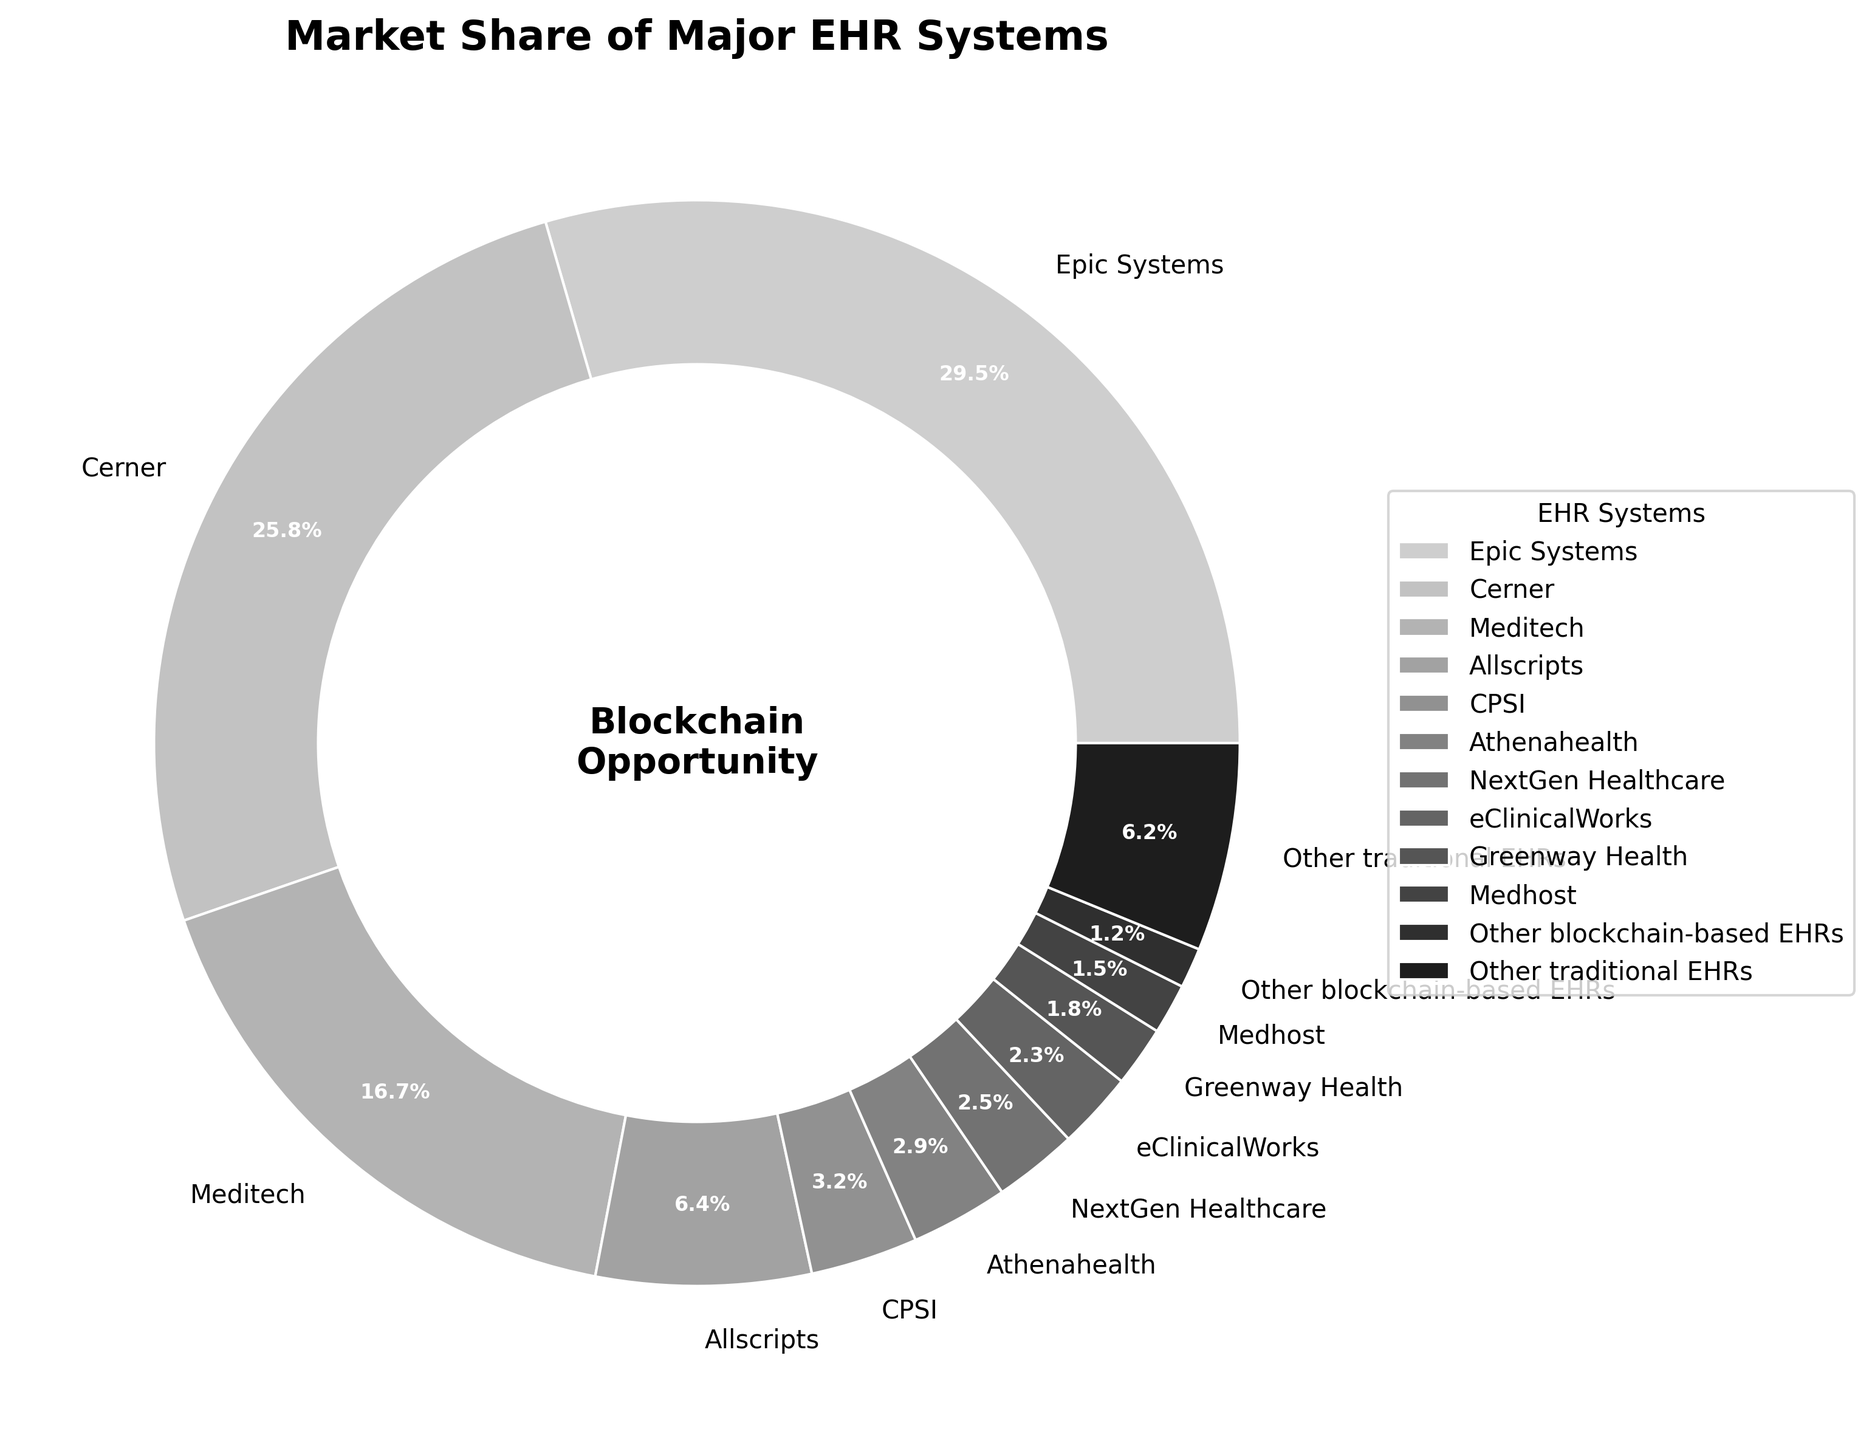Which EHR system has the highest market share? The pie chart shows the market share distribution of various EHR systems with Epic Systems having the largest slice.
Answer: Epic Systems What is the combined market share of Epic Systems and Cerner? To find the combined market share, add the percentages of Epic Systems (29.5%) and Cerner (25.8%). The total is 29.5 + 25.8 = 55.3%.
Answer: 55.3% Which two EHR systems have nearly equal market shares? The chart shows Athenahealth with 2.9% and NextGen Healthcare with 2.5%, which are close to each other in market share.
Answer: Athenahealth and NextGen Healthcare What is the difference in market share between Epic Systems and Meditech? To find the difference, subtract Meditech's share (16.7%) from Epic Systems' share (29.5%). The difference is 29.5 - 16.7 = 12.8%.
Answer: 12.8% Which EHR systems occupy less than 5% of the market share each? The EHR systems with less than 5% market share are Allscripts (6.4%), CPSI (3.2%), Athenahealth (2.9%), NextGen Healthcare (2.5%), eClinicalWorks (2.3%), Greenway Health (1.8%), Medhost (1.5%), other blockchain-based EHRs (1.2%), and other traditional EHRs (6.2%). We exclude 'Other traditional EHRs' since it has 6.2%, which is more than 5%.
Answer: Allscripts, CPSI, Athenahealth, NextGen Healthcare, eClinicalWorks, Greenway Health, Medhost, other blockchain-based EHRs What is the total market share held by blockchain-based EHR systems as indicated in the figure? The figure explicitly shows 'Other blockchain-based EHRs' with a market share of 1.2%.
Answer: 1.2% How much larger is Epic Systems' market share compared to Athenahealth? Subtract Athenahealth's market share (2.9%) from Epic Systems' market share (29.5%). The difference is 29.5 - 2.9 = 26.6%.
Answer: 26.6% Name the three EHR systems with the smallest market share according to the chart. The EHR systems with the smallest market shares are Medhost (1.5%), other blockchain-based EHRs (1.2%), and other traditional EHRs (6.2%). Given that 'other traditional EHRs' represents a combined category, we consider eClinicalWorks (2.3%) as the third smallest individual entity.
Answer: Medhost, other blockchain-based EHRs, eClinicalWorks What is the combined market share of all EHR systems that have less than 3% market share? To calculate this, identify systems with market shares below 3%: CPSI (3.2%), Athenahealth (2.9%), NextGen Healthcare (2.5%), eClinicalWorks (2.3%), Greenway Health (1.8%), Medhost (1.5%), and other blockchain-based EHRs (1.2%). Add the relevant shares: 2.9 + 2.5 + 2.3 + 1.8 + 1.5 + 1.2 = 12.2%.
Answer: 12.2% Which category represents the opportunity for blockchain in the text on the figure? The pie chart text highlights "Blockchain Opportunity" in the central circle.
Answer: Blockchain Opportunity 